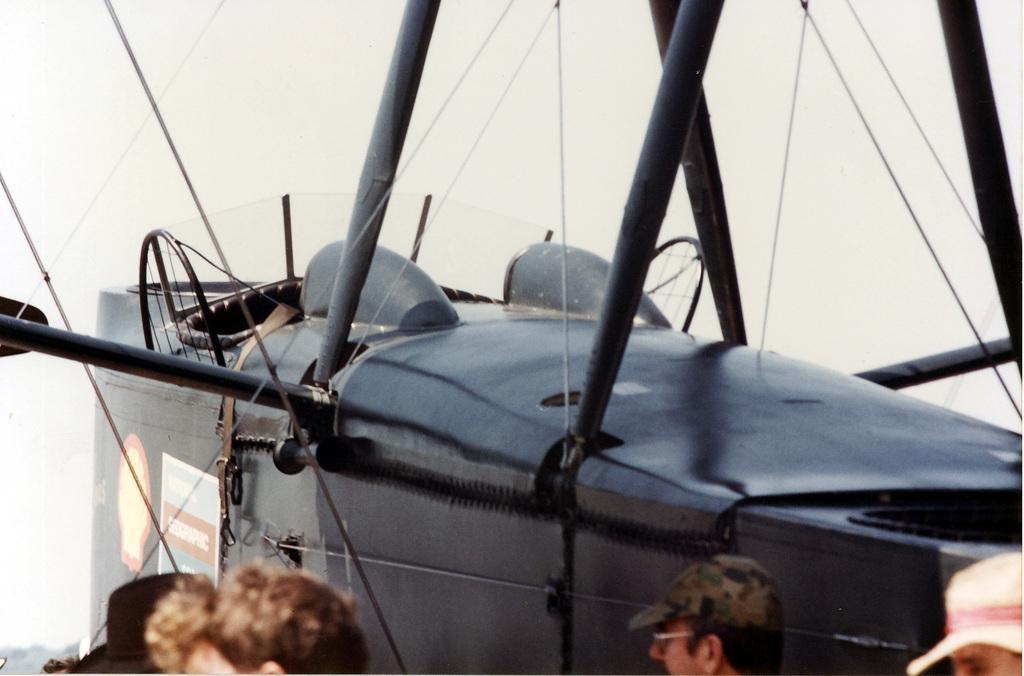Can you describe this image briefly? In this image I can see a group of people, vehicle like object, metal rods, trees and the sky. This image is taken may be during a day. 